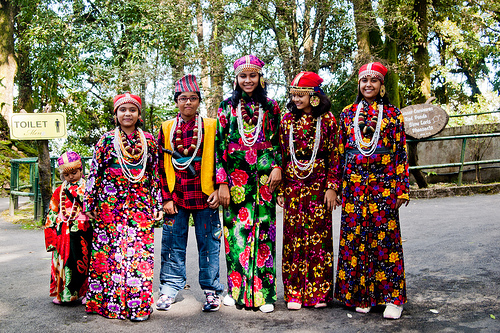<image>
Is the girl next to the signage? Yes. The girl is positioned adjacent to the signage, located nearby in the same general area. 